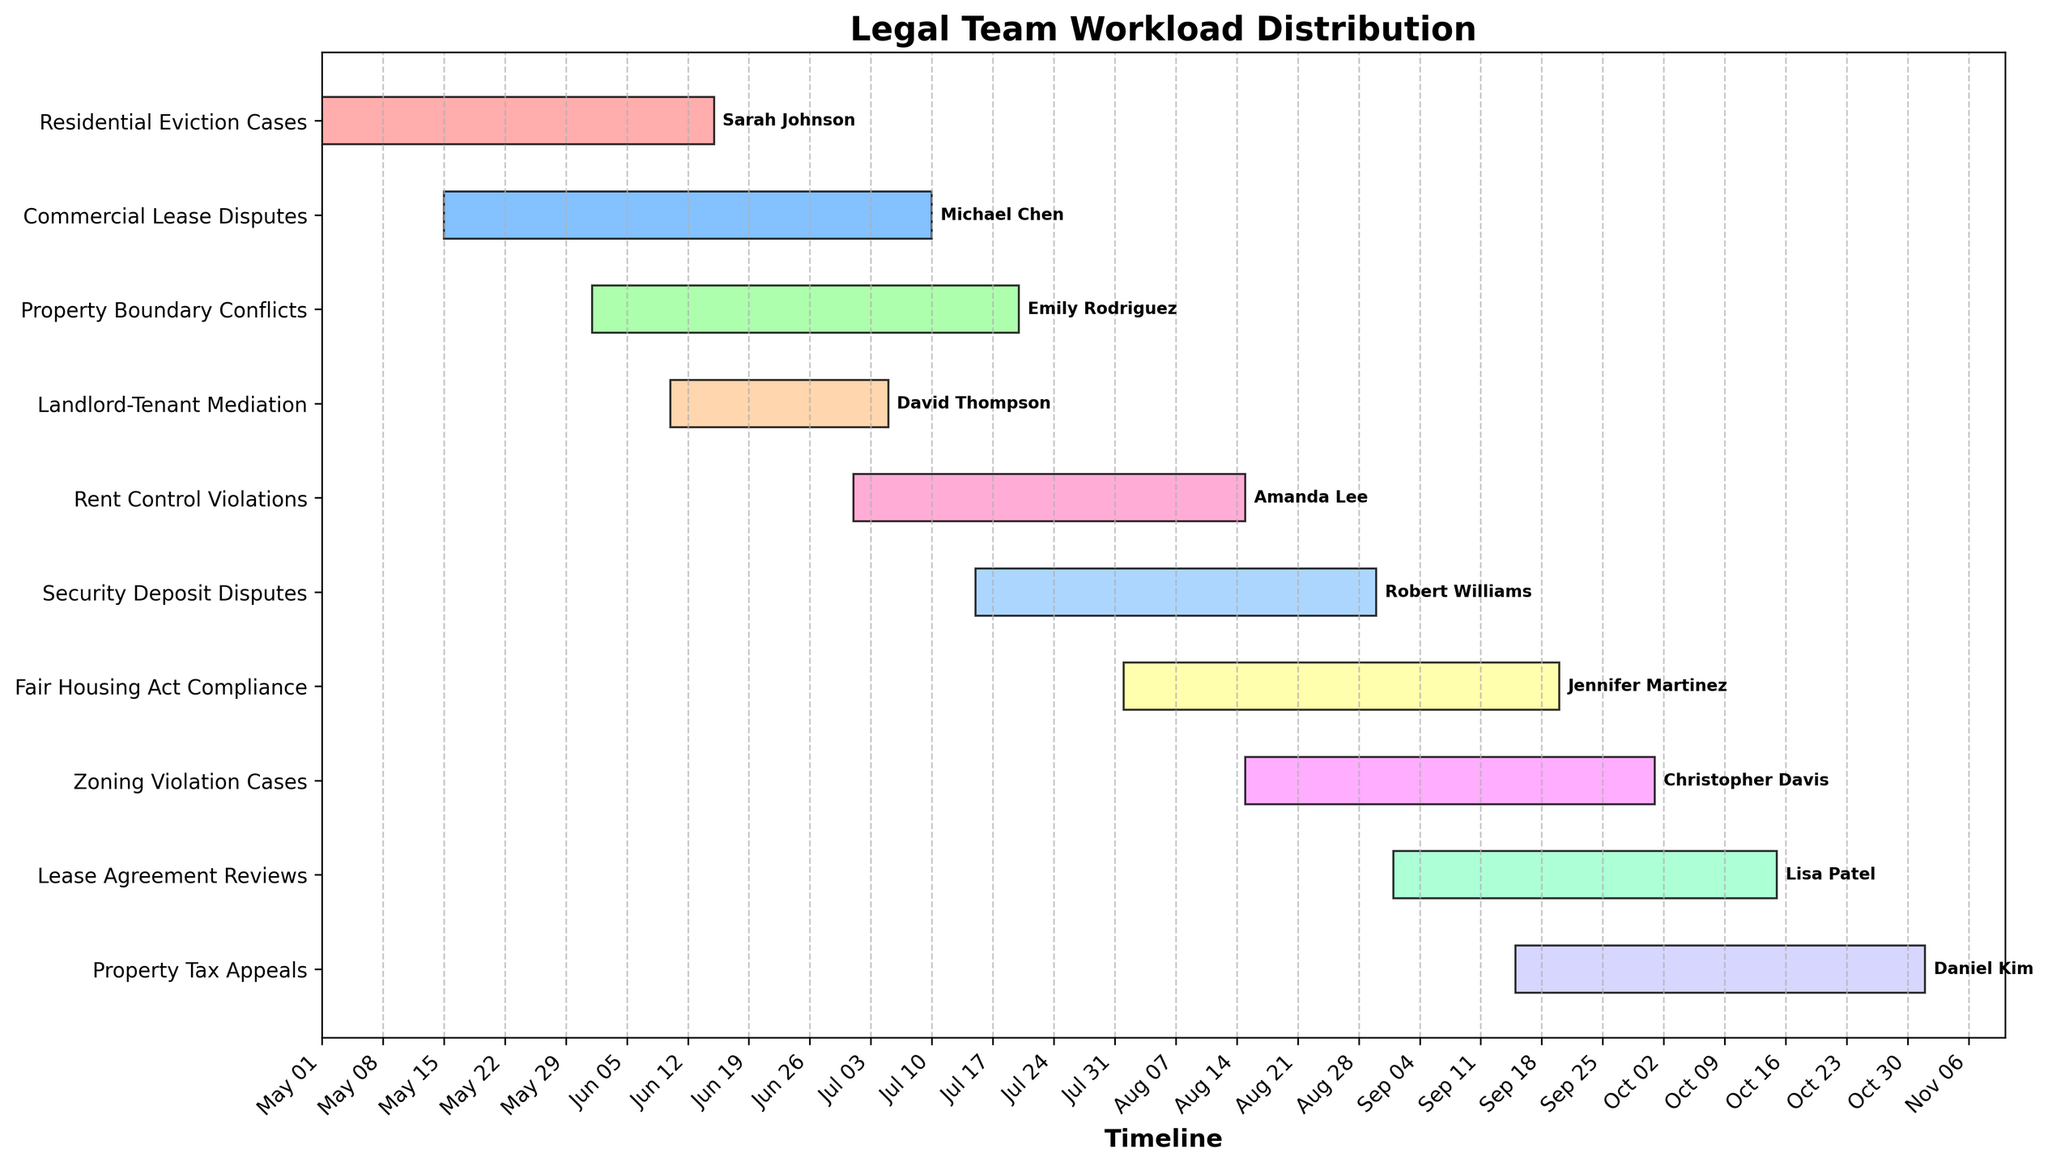How many different tasks are listed in the Gantt chart? Count the number of tasks along the y-axis. There are 10 different tasks listed.
Answer: 10 Who is assigned to handle Residential Eviction Cases? Look at the task labeled "Residential Eviction Cases" and check the name next to it. Sarah Johnson is assigned to this task.
Answer: Sarah Johnson Which task starts first on the timeline? Compare the start dates of all tasks along the x-axis. The task "Residential Eviction Cases" starts first on May 1, 2023.
Answer: Residential Eviction Cases What is the duration of the "Property Tax Appeals" task? Calculate the number of days between the start date (September 15, 2023) and the end date (November 1, 2023). The duration is 47 days.
Answer: 47 days Which tasks have overlapping time periods? Look for tasks that bar sections overlap on the timeline. "Rent Control Violations" overlaps with "Security Deposit Disputes," "Fair Housing Act Compliance," and "Zoning Violation Cases."
Answer: Rent Control Violations, Security Deposit Disputes, Fair Housing Act Compliance, Zoning Violation Cases How long is the "Commercial Lease Disputes" task compared to the "Landlord-Tenant Mediation"? Calculate and compare the number of days for each task. "Commercial Lease Disputes" (May 15 to July 10, 2023) is 56 days, while "Landlord-Tenant Mediation" (June 10 to July 5, 2023) is 25 days. The difference is 31 days.
Answer: 31 days longer Are there any tasks assigned to the same person? Check the names next to each task for repetitions. Each person is assigned to only one task, no repetitions are found.
Answer: No Which task ends last on the timeline? Compare the end dates of all tasks along the x-axis. The task "Property Tax Appeals" ends last on November 1, 2023.
Answer: Property Tax Appeals Which tasks are handled by team members with names that start with "S"? Find tasks assigned to names starting with "S" (Sarah Johnson and Susan) and list those tasks. Only "Sarah Johnson" handles tasks, specifically "Residential Eviction Cases."
Answer: Residential Eviction Cases 